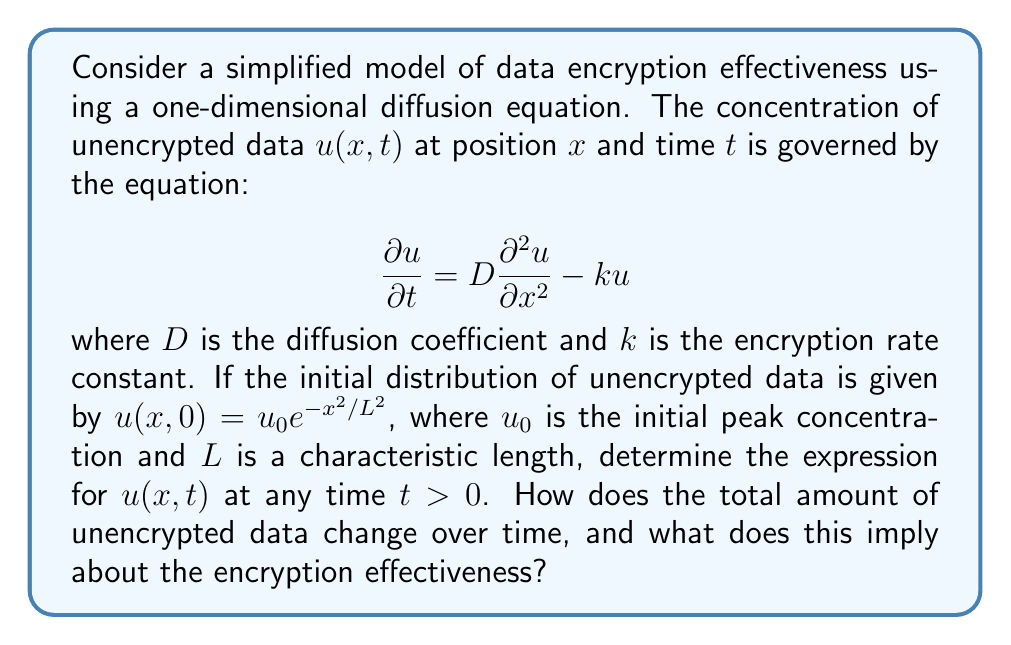Solve this math problem. To solve this problem, we'll follow these steps:

1) The given equation is a linear partial differential equation (PDE) that combines diffusion and decay terms. We can solve it using the method of separation of variables and Fourier transform.

2) Let's assume a solution of the form $u(x,t) = X(x)T(t)$. Substituting this into the PDE:

   $$X(x)\frac{dT}{dt} = DT(t)\frac{d^2X}{dx^2} - kX(x)T(t)$$

3) Dividing both sides by $X(x)T(t)$:

   $$\frac{1}{T}\frac{dT}{dt} = D\frac{1}{X}\frac{d^2X}{dx^2} - k$$

4) The left side is a function of $t$ only, and the right side is a function of $x$ only. For this to be true for all $x$ and $t$, both sides must equal a constant, say $-\lambda^2$. This gives us two ordinary differential equations:

   $$\frac{dT}{dt} = -(\lambda^2 + k)T$$
   $$\frac{d^2X}{dx^2} + \frac{\lambda^2}{D}X = 0$$

5) The solution for $T(t)$ is:

   $$T(t) = e^{-(\lambda^2 + k)t}$$

6) The solution for $X(x)$ is:

   $$X(x) = A\cos(\lambda x/\sqrt{D}) + B\sin(\lambda x/\sqrt{D})$$

7) However, given the initial condition $u(x,0) = u_0 e^{-x^2/L^2}$, we need to use Fourier transform to find the complete solution. The Fourier transform of the initial condition is:

   $$\hat{u}(\omega,0) = u_0 L \sqrt{\pi} e^{-L^2\omega^2/4}$$

8) The solution in Fourier space is:

   $$\hat{u}(\omega,t) = \hat{u}(\omega,0) e^{-(D\omega^2 + k)t}$$

9) Taking the inverse Fourier transform:

   $$u(x,t) = \frac{u_0 L}{\sqrt{L^2 + 4Dt}} \exp\left(-\frac{x^2}{L^2 + 4Dt} - kt\right)$$

10) To find how the total amount of unencrypted data changes over time, we integrate $u(x,t)$ over all $x$:

    $$\int_{-\infty}^{\infty} u(x,t) dx = u_0 L \sqrt{\pi} e^{-kt}$$

This shows that the total amount of unencrypted data decays exponentially with time, with a decay rate of $k$.
Answer: The solution to the diffusion-decay equation for data encryption effectiveness is:

$$u(x,t) = \frac{u_0 L}{\sqrt{L^2 + 4Dt}} \exp\left(-\frac{x^2}{L^2 + 4Dt} - kt\right)$$

The total amount of unencrypted data decays exponentially over time:

$$\int_{-\infty}^{\infty} u(x,t) dx = u_0 L \sqrt{\pi} e^{-kt}$$

This implies that the encryption is effective, with the amount of unencrypted data decreasing at a rate determined by the encryption rate constant $k$. The diffusion term causes the data to spread out spatially over time, but does not affect the total amount of unencrypted data. 